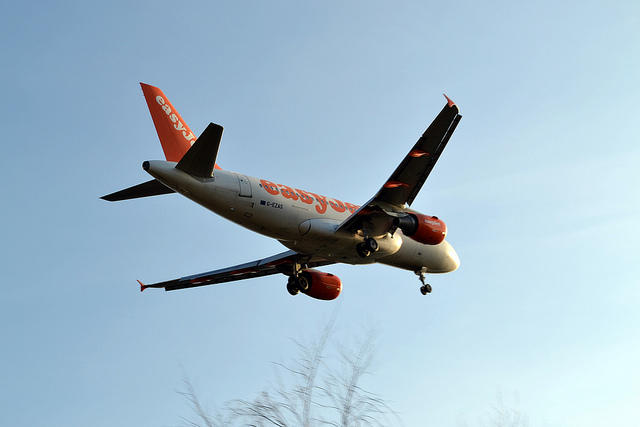Identify and read out the text in this image. easyJ easy 